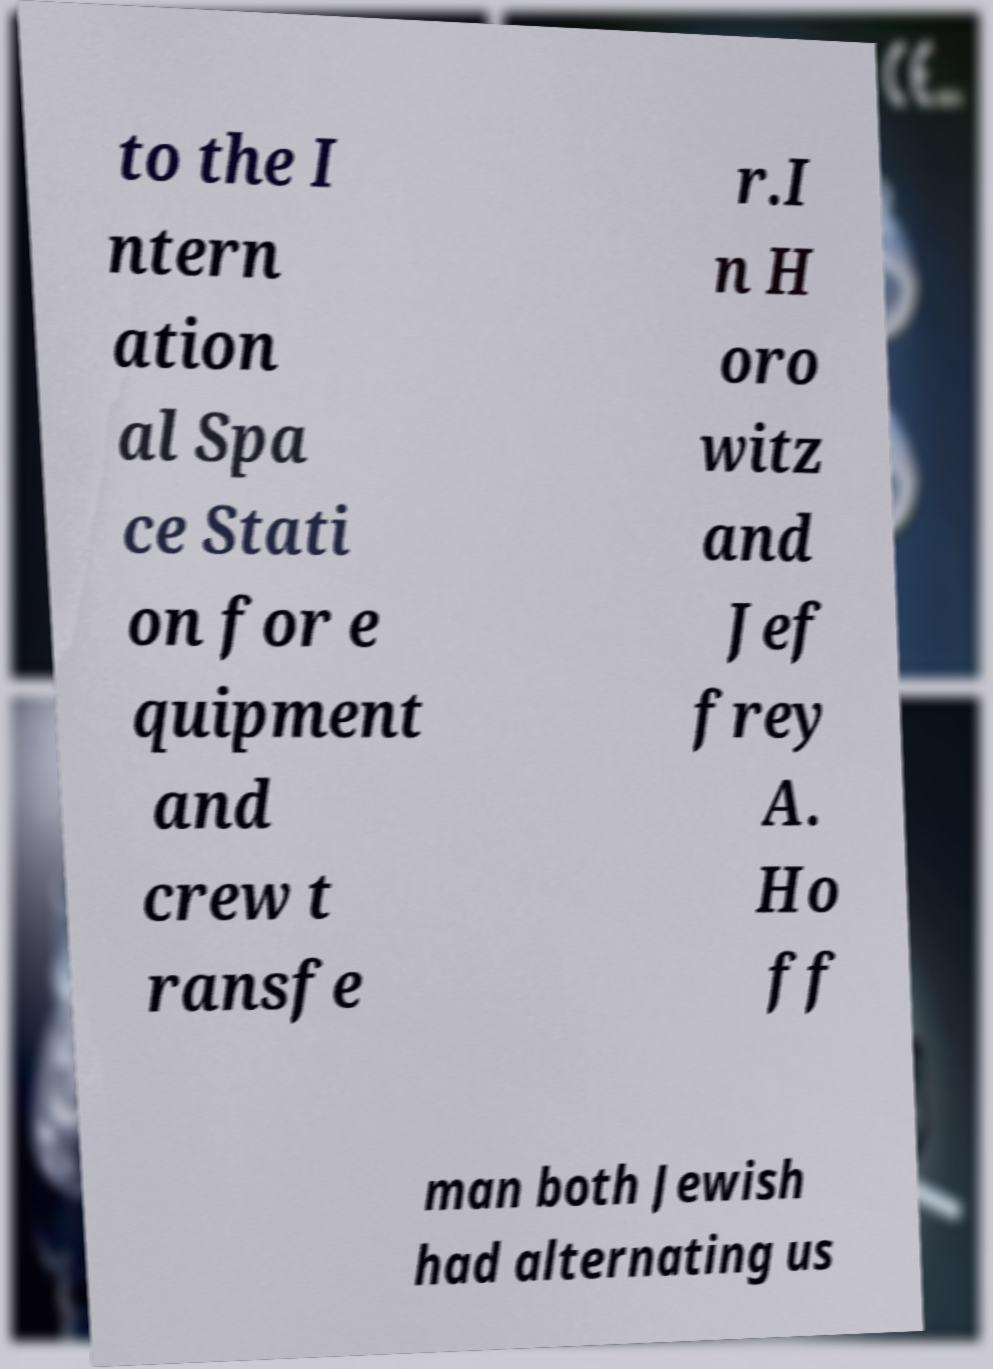Please identify and transcribe the text found in this image. to the I ntern ation al Spa ce Stati on for e quipment and crew t ransfe r.I n H oro witz and Jef frey A. Ho ff man both Jewish had alternating us 